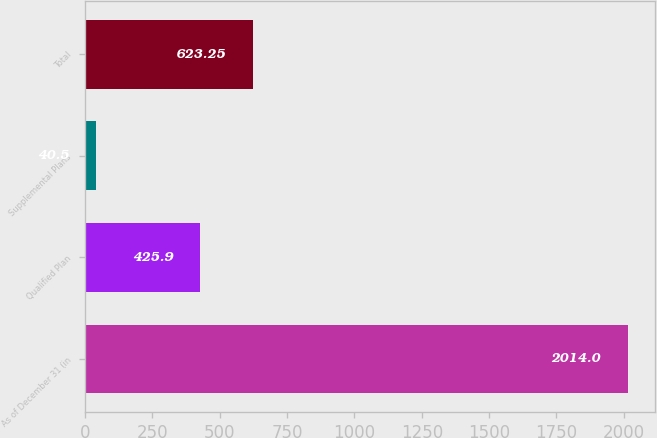Convert chart. <chart><loc_0><loc_0><loc_500><loc_500><bar_chart><fcel>As of December 31 (in<fcel>Qualified Plan<fcel>Supplemental Plans<fcel>Total<nl><fcel>2014<fcel>425.9<fcel>40.5<fcel>623.25<nl></chart> 